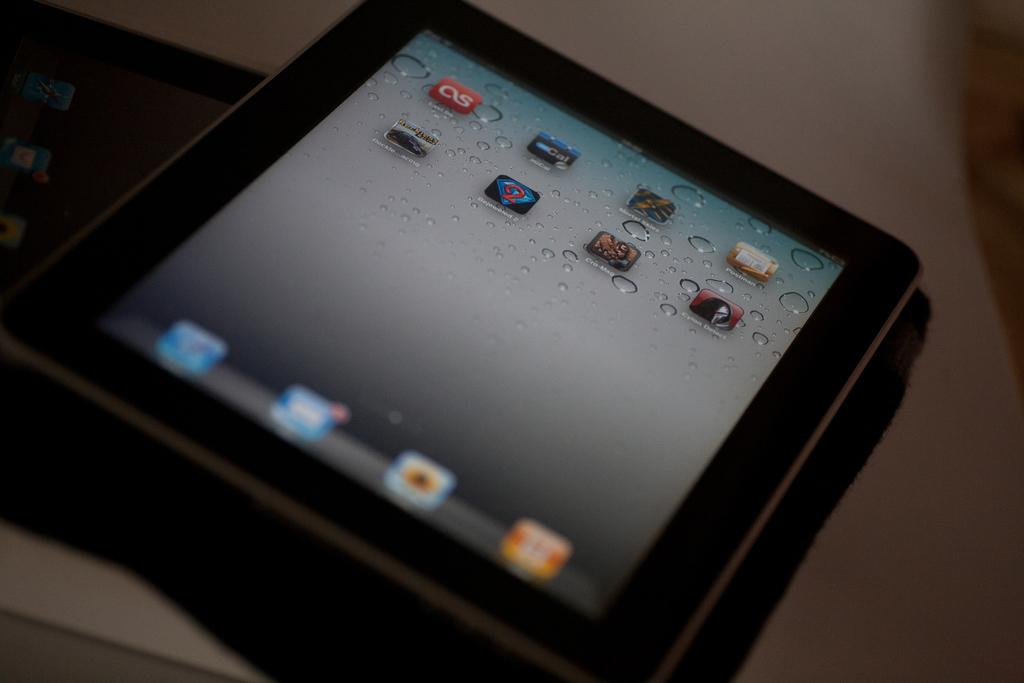How many tablets are present in the image? There are two tablets in the image. How are the tablets arranged in the image? The tablets are stacked one on top of the other. What can be seen on the screens of the tablets? App icons are visible on the screens of the tablets. Where are the tablets located in the image? The tablets are placed on a table. Who is participating in the competition on the tablets in the image? There is no competition present in the image; the tablets are simply stacked with app icons visible on their screens. 